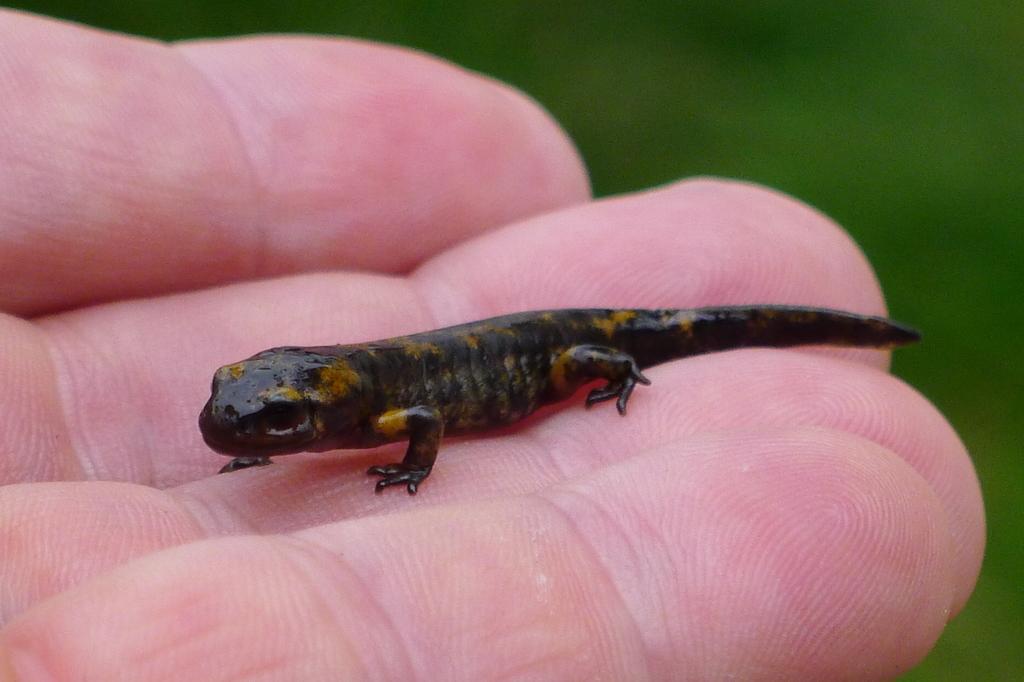Could you give a brief overview of what you see in this image? In this picture I can see there is a small black color lizard. There is a person holding it in his hand. 